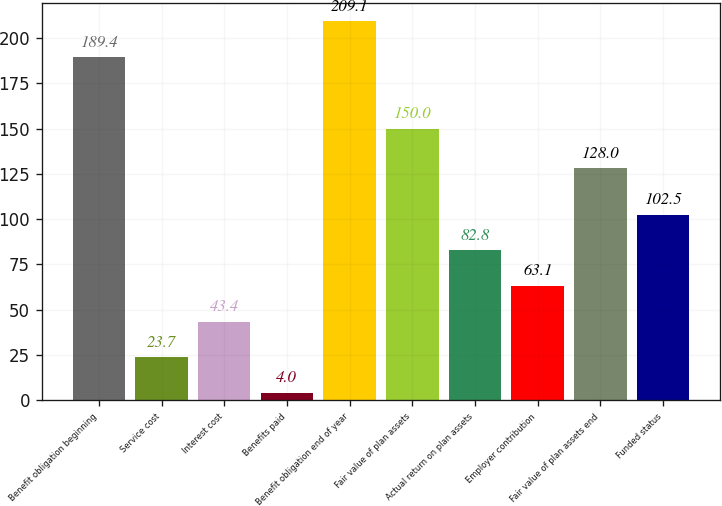<chart> <loc_0><loc_0><loc_500><loc_500><bar_chart><fcel>Benefit obligation beginning<fcel>Service cost<fcel>Interest cost<fcel>Benefits paid<fcel>Benefit obligation end of year<fcel>Fair value of plan assets<fcel>Actual return on plan assets<fcel>Employer contribution<fcel>Fair value of plan assets end<fcel>Funded status<nl><fcel>189.4<fcel>23.7<fcel>43.4<fcel>4<fcel>209.1<fcel>150<fcel>82.8<fcel>63.1<fcel>128<fcel>102.5<nl></chart> 